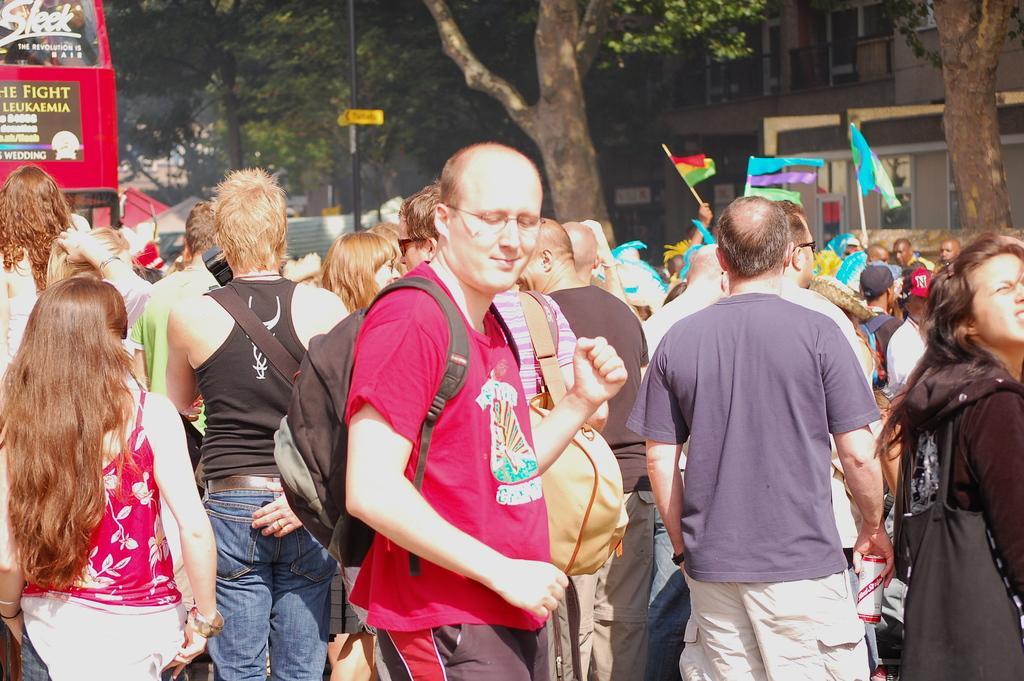Please provide a concise description of this image. In the image we can see there are lot of people standing and they are carrying bags. Behind there are trees and buildings. There is a vehicle parked on the road. 